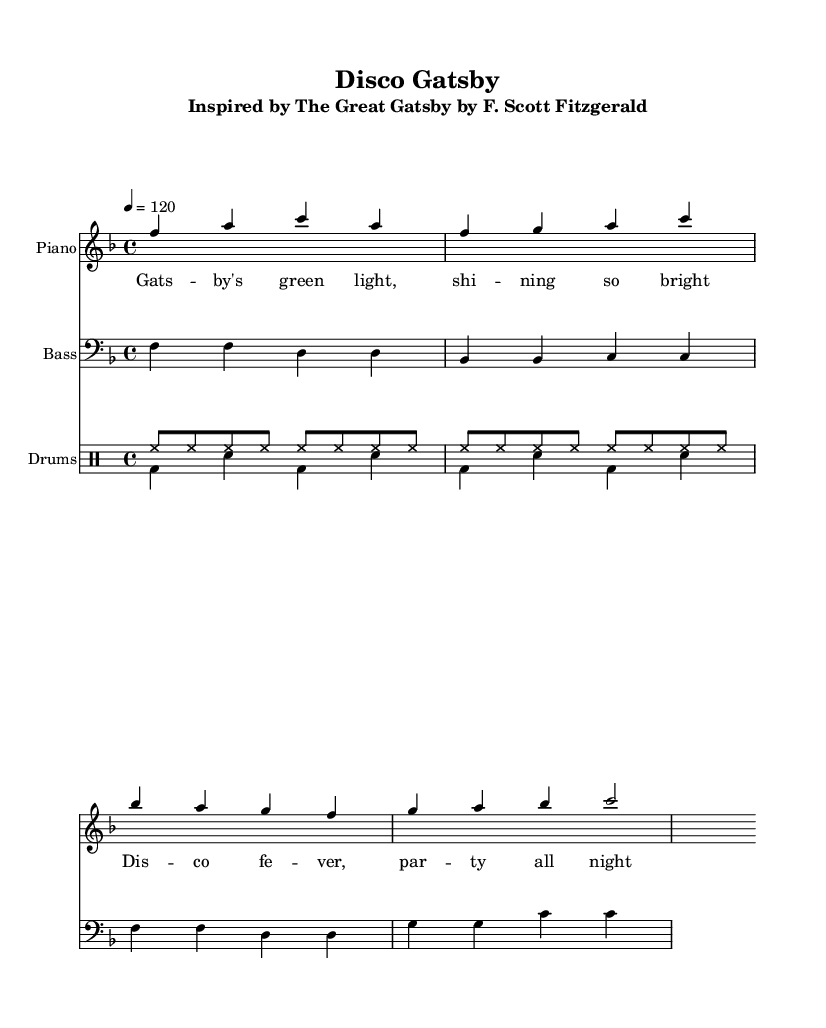What is the key signature of this music? The key signature is identified at the beginning of the staff, where the F major key signature has one flat, specifically Bb.
Answer: F major What is the time signature of this music? The time signature is found at the start of the score, indicated by numbers. In this case, it is 4 over 4, meaning there are four beats in each measure.
Answer: 4/4 What is the tempo marking of this piece? The tempo marking is noted with a number at the beginning, indicating the beats per minute. Here, it states '4 = 120', signifying that there are 120 beats per minute.
Answer: 120 How many measures are in the electric piano part? Counting the vertical lines (bar lines) in the electric piano section shows that there are four measures in total.
Answer: 4 What rhythmic pattern is used in the drum section labeled "drumsUp"? The "drumsUp" section has a consistent pattern of eighth notes represented as 'hh' for hi-hat, which appear in sequences across the measures. Therefore, it contains a rhythmic pattern of continuous eighth notes.
Answer: Eighth notes What type of musical form does this piece predominantly follow? Analyzing the structure, it consists of repeated sections which indicates that it is structured as a verse or chorus typical to dance music, often repeating motifs.
Answer: Repetitive What is the thematic inspiration for the lyrics written in the music? The lyrics reference a significant symbol from the novel "The Great Gatsby," specifically the green light and the party atmosphere emphasized throughout the text, relating to key themes in the book.
Answer: The Great Gatsby 